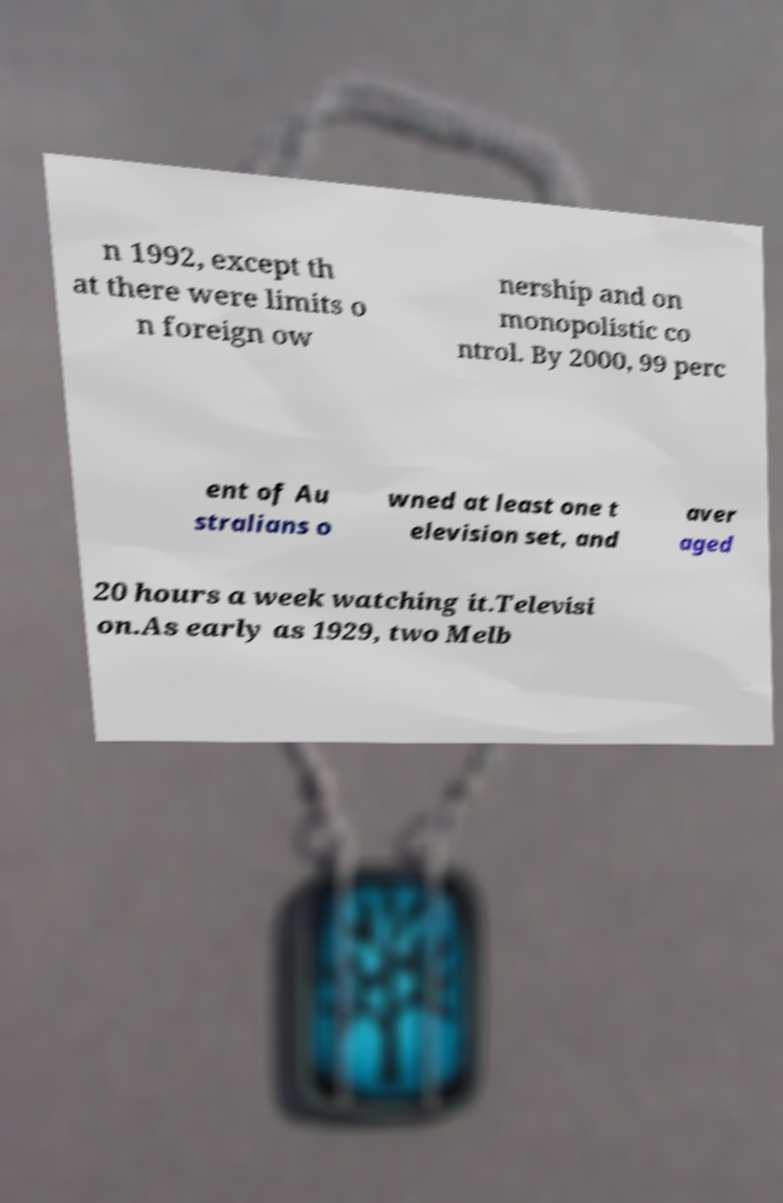For documentation purposes, I need the text within this image transcribed. Could you provide that? n 1992, except th at there were limits o n foreign ow nership and on monopolistic co ntrol. By 2000, 99 perc ent of Au stralians o wned at least one t elevision set, and aver aged 20 hours a week watching it.Televisi on.As early as 1929, two Melb 